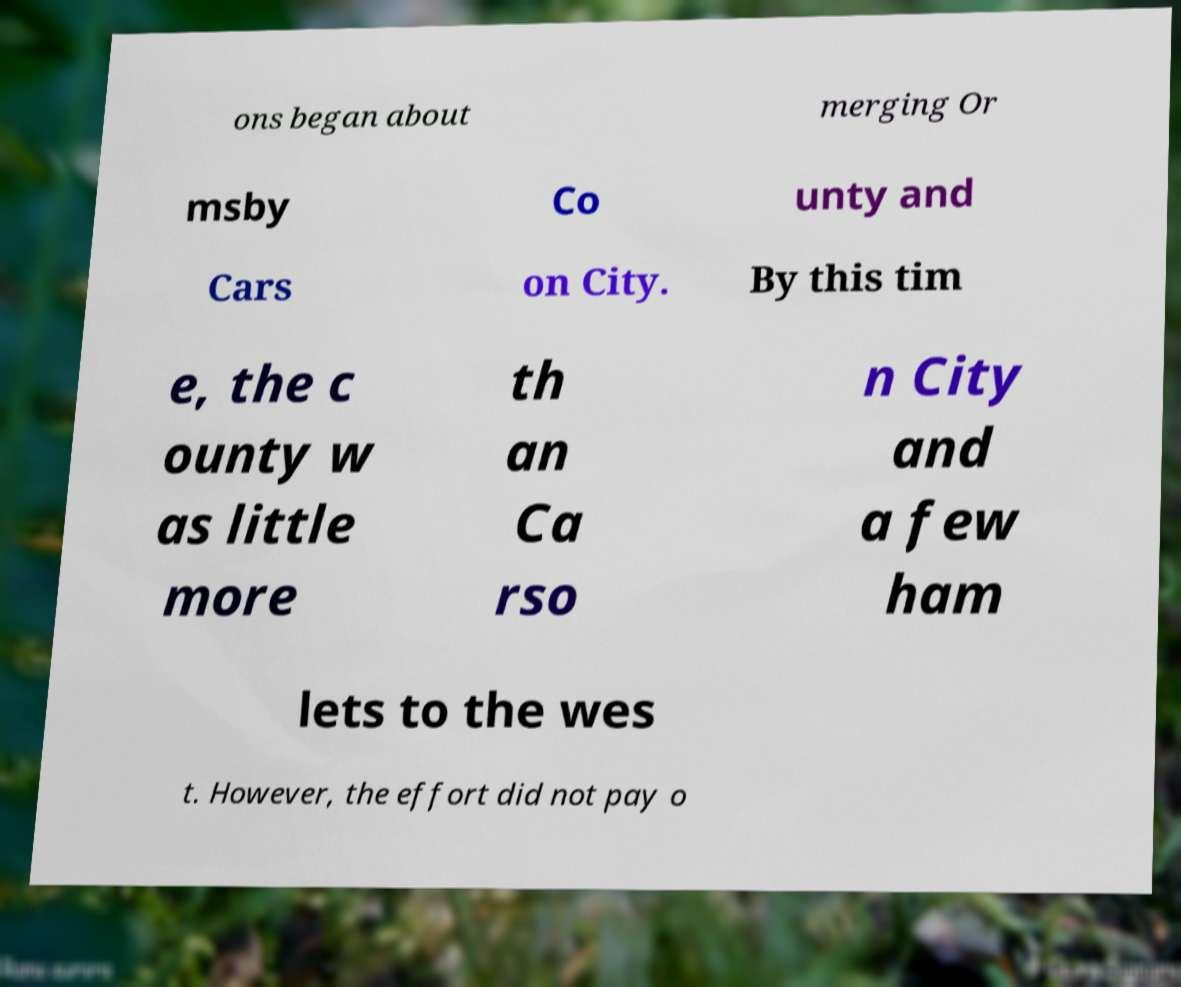Please read and relay the text visible in this image. What does it say? ons began about merging Or msby Co unty and Cars on City. By this tim e, the c ounty w as little more th an Ca rso n City and a few ham lets to the wes t. However, the effort did not pay o 